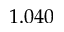Convert formula to latex. <formula><loc_0><loc_0><loc_500><loc_500>1 . 0 4 0</formula> 